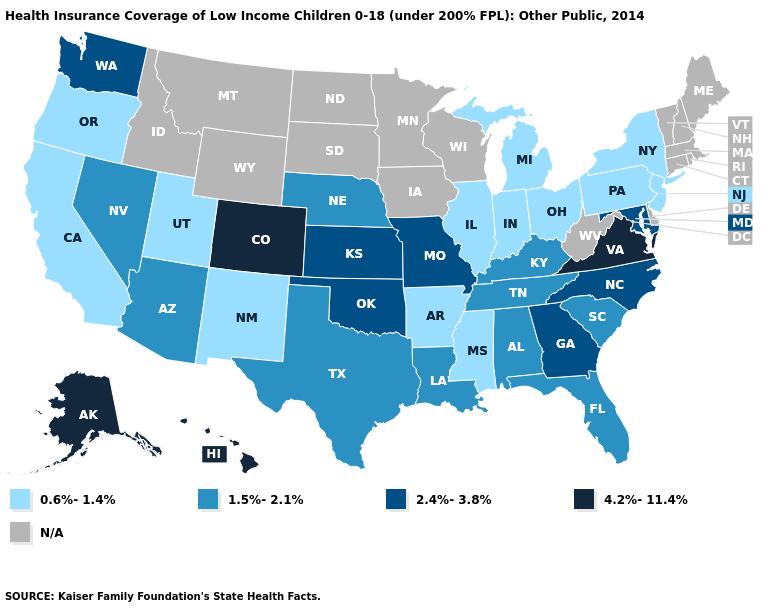Name the states that have a value in the range 0.6%-1.4%?
Short answer required. Arkansas, California, Illinois, Indiana, Michigan, Mississippi, New Jersey, New Mexico, New York, Ohio, Oregon, Pennsylvania, Utah. What is the value of South Carolina?
Write a very short answer. 1.5%-2.1%. What is the lowest value in the USA?
Write a very short answer. 0.6%-1.4%. Name the states that have a value in the range 4.2%-11.4%?
Be succinct. Alaska, Colorado, Hawaii, Virginia. What is the lowest value in the West?
Be succinct. 0.6%-1.4%. What is the value of Montana?
Keep it brief. N/A. Name the states that have a value in the range 1.5%-2.1%?
Answer briefly. Alabama, Arizona, Florida, Kentucky, Louisiana, Nebraska, Nevada, South Carolina, Tennessee, Texas. Is the legend a continuous bar?
Concise answer only. No. Does the map have missing data?
Write a very short answer. Yes. Is the legend a continuous bar?
Concise answer only. No. Name the states that have a value in the range 0.6%-1.4%?
Be succinct. Arkansas, California, Illinois, Indiana, Michigan, Mississippi, New Jersey, New Mexico, New York, Ohio, Oregon, Pennsylvania, Utah. Name the states that have a value in the range 4.2%-11.4%?
Keep it brief. Alaska, Colorado, Hawaii, Virginia. What is the highest value in the South ?
Short answer required. 4.2%-11.4%. Does the map have missing data?
Concise answer only. Yes. Name the states that have a value in the range 2.4%-3.8%?
Quick response, please. Georgia, Kansas, Maryland, Missouri, North Carolina, Oklahoma, Washington. 